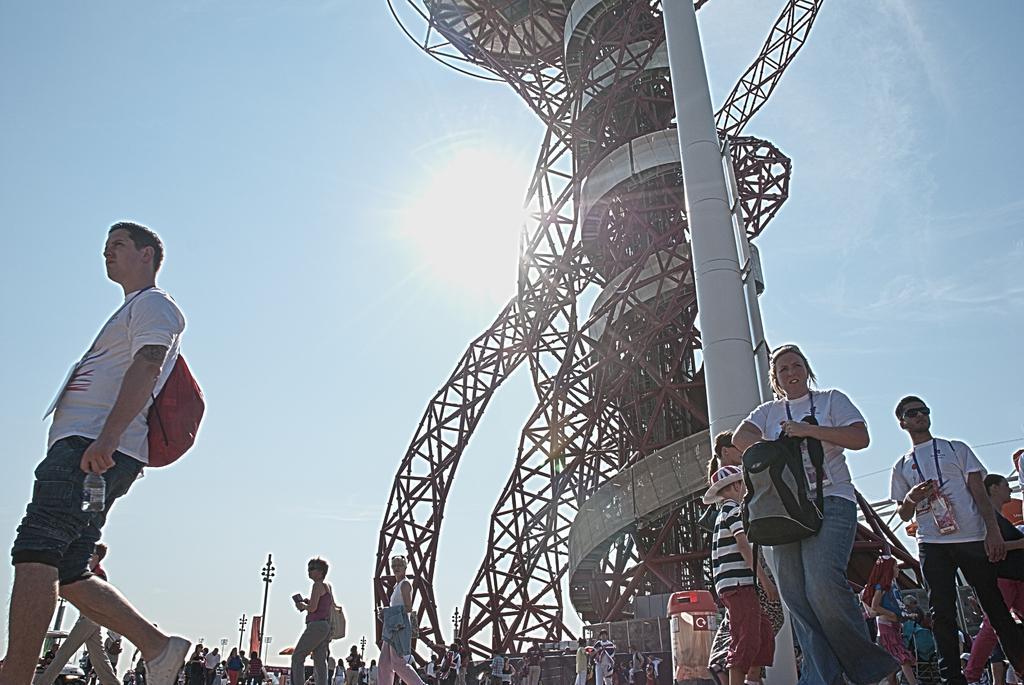Describe this image in one or two sentences. In the picture I can see these people are walking on the road, I can see tower, poles, few objects and I can see the sun in the sky. 